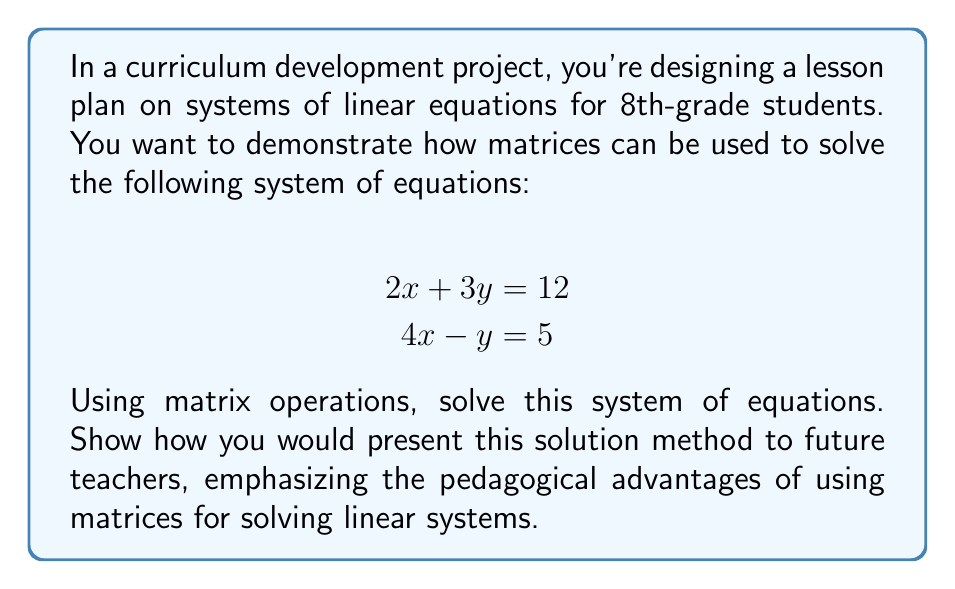Teach me how to tackle this problem. 1. First, we'll show how to represent the system of equations as a matrix equation:

   $$\begin{bmatrix}
   2 & 3 \\
   4 & -1
   \end{bmatrix}
   \begin{bmatrix}
   x \\
   y
   \end{bmatrix} =
   \begin{bmatrix}
   12 \\
   5
   \end{bmatrix}$$

   Pedagogical advantage: This visual representation helps students see the structure of the system clearly.

2. To solve this, we need to find the inverse of the coefficient matrix:

   $$A = \begin{bmatrix}
   2 & 3 \\
   4 & -1
   \end{bmatrix}$$

   $$det(A) = (2)(-1) - (3)(4) = -2 - 12 = -14$$

   $$A^{-1} = \frac{1}{-14}\begin{bmatrix}
   -1 & -3 \\
   -4 & 2
   \end{bmatrix} = \begin{bmatrix}
   \frac{1}{14} & \frac{3}{14} \\
   \frac{2}{7} & -\frac{1}{7}
   \end{bmatrix}$$

   Pedagogical advantage: This step reinforces the concept of matrix inverse and its role in solving systems.

3. Now, we can solve for x and y:

   $$\begin{bmatrix}
   x \\
   y
   \end{bmatrix} = 
   \begin{bmatrix}
   \frac{1}{14} & \frac{3}{14} \\
   \frac{2}{7} & -\frac{1}{7}
   \end{bmatrix}
   \begin{bmatrix}
   12 \\
   5
   \end{bmatrix}$$

   $$\begin{bmatrix}
   x \\
   y
   \end{bmatrix} = 
   \begin{bmatrix}
   \frac{1}{14}(12) + \frac{3}{14}(5) \\
   \frac{2}{7}(12) + (-\frac{1}{7})(5)
   \end{bmatrix} = 
   \begin{bmatrix}
   \frac{12 + 15}{14} \\
   \frac{24 - 5}{7}
   \end{bmatrix} = 
   \begin{bmatrix}
   2 \\
   \frac{19}{7}
   \end{bmatrix}$$

   Pedagogical advantage: This method demonstrates how matrix multiplication can be used to solve systems efficiently.

4. Therefore, $x = 2$ and $y = \frac{19}{7}$.

When presenting this to future teachers, emphasize that using matrices:
- Provides a systematic approach to solving systems of equations
- Introduces important concepts in linear algebra
- Can be easily extended to larger systems of equations
- Helps visualize the structure of the system
- Prepares students for more advanced mathematical concepts
Answer: $x = 2$, $y = \frac{19}{7}$ 